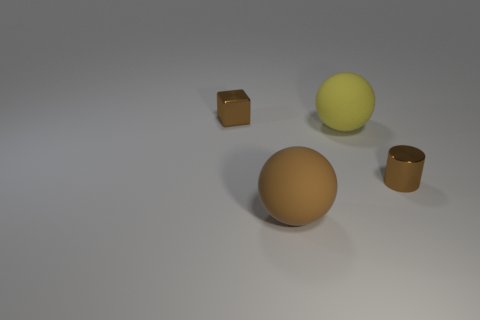What is the shape of the tiny shiny object that is the same color as the cube?
Your answer should be compact. Cylinder. Is there a block that has the same color as the tiny cylinder?
Keep it short and to the point. Yes. How many blue shiny objects have the same size as the brown metallic cylinder?
Provide a succinct answer. 0. Are the object that is on the right side of the yellow object and the block made of the same material?
Provide a short and direct response. Yes. Are there fewer tiny metallic blocks in front of the brown cylinder than tiny yellow cylinders?
Ensure brevity in your answer.  No. What is the shape of the thing that is on the left side of the brown rubber sphere?
Provide a succinct answer. Cube. There is a yellow matte thing that is the same size as the brown rubber ball; what shape is it?
Provide a short and direct response. Sphere. Is there a tiny blue shiny thing that has the same shape as the big brown object?
Your answer should be very brief. No. Is the shape of the rubber thing behind the brown shiny cylinder the same as the tiny metal thing that is to the right of the small block?
Your answer should be compact. No. There is another ball that is the same size as the yellow rubber sphere; what material is it?
Provide a short and direct response. Rubber. 